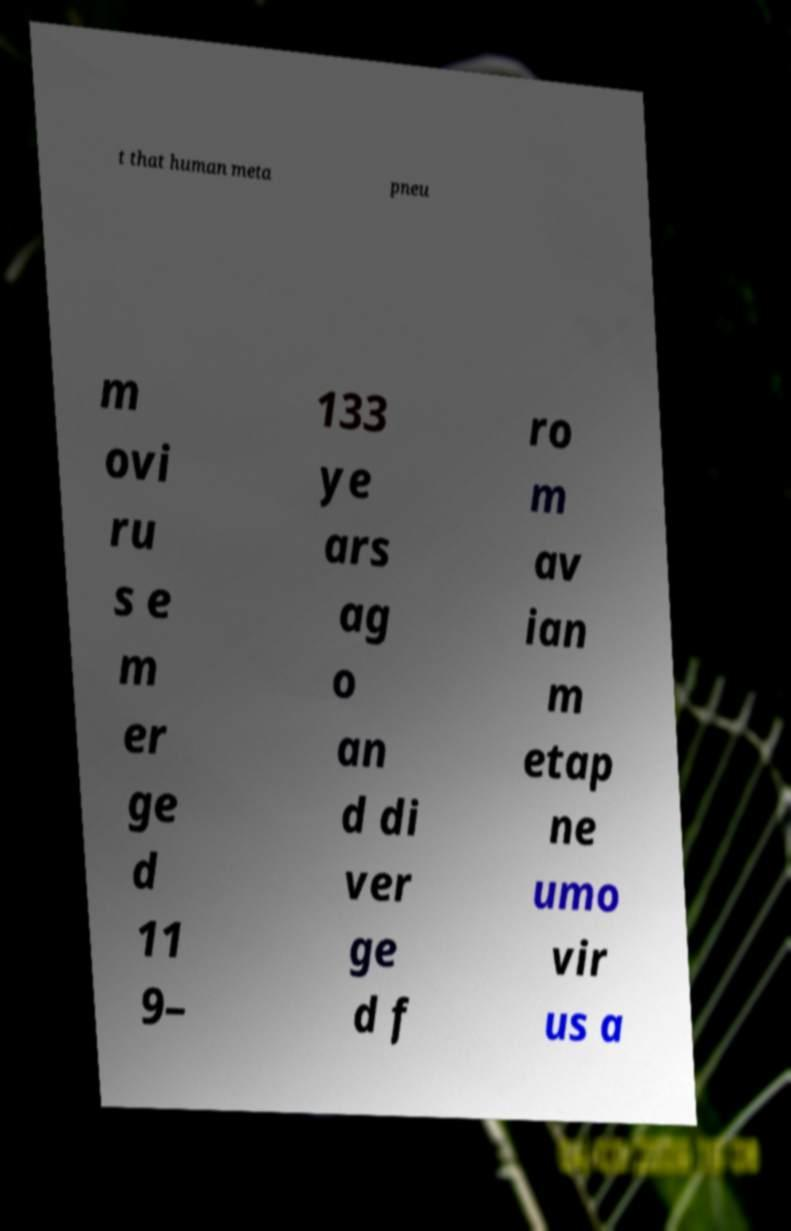What messages or text are displayed in this image? I need them in a readable, typed format. t that human meta pneu m ovi ru s e m er ge d 11 9– 133 ye ars ag o an d di ver ge d f ro m av ian m etap ne umo vir us a 